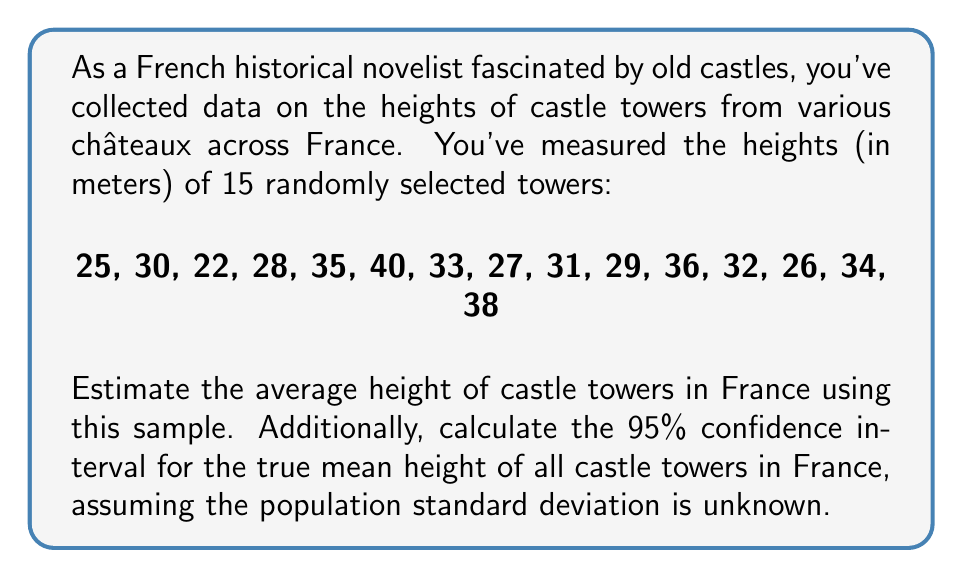Show me your answer to this math problem. To solve this problem, we'll follow these steps:

1. Calculate the sample mean
2. Calculate the sample standard deviation
3. Determine the t-value for a 95% confidence interval
4. Calculate the margin of error
5. Compute the confidence interval

Step 1: Calculate the sample mean
The sample mean ($\bar{x}$) is calculated as:

$$\bar{x} = \frac{\sum_{i=1}^{n} x_i}{n}$$

Where $x_i$ are the individual values and $n$ is the sample size.

$$\bar{x} = \frac{25 + 30 + 22 + 28 + 35 + 40 + 33 + 27 + 31 + 29 + 36 + 32 + 26 + 34 + 38}{15} = \frac{466}{15} = 31.067$$

Step 2: Calculate the sample standard deviation
The sample standard deviation ($s$) is calculated as:

$$s = \sqrt{\frac{\sum_{i=1}^{n} (x_i - \bar{x})^2}{n - 1}}$$

Calculating this:

$$s = \sqrt{\frac{(25-31.067)^2 + (30-31.067)^2 + ... + (38-31.067)^2}{15 - 1}} = 5.185$$

Step 3: Determine the t-value
For a 95% confidence interval with 14 degrees of freedom (n-1), the t-value is approximately 2.145 (from t-distribution tables).

Step 4: Calculate the margin of error
The margin of error (ME) is calculated as:

$$ME = t_{\alpha/2, n-1} \cdot \frac{s}{\sqrt{n}}$$

$$ME = 2.145 \cdot \frac{5.185}{\sqrt{15}} = 2.872$$

Step 5: Compute the confidence interval
The confidence interval is calculated as:

$$(\bar{x} - ME, \bar{x} + ME)$$

$$(31.067 - 2.872, 31.067 + 2.872) = (28.195, 33.939)$$
Answer: The estimated average height of castle towers in France is 31.067 meters, with a 95% confidence interval of (28.195, 33.939) meters. 